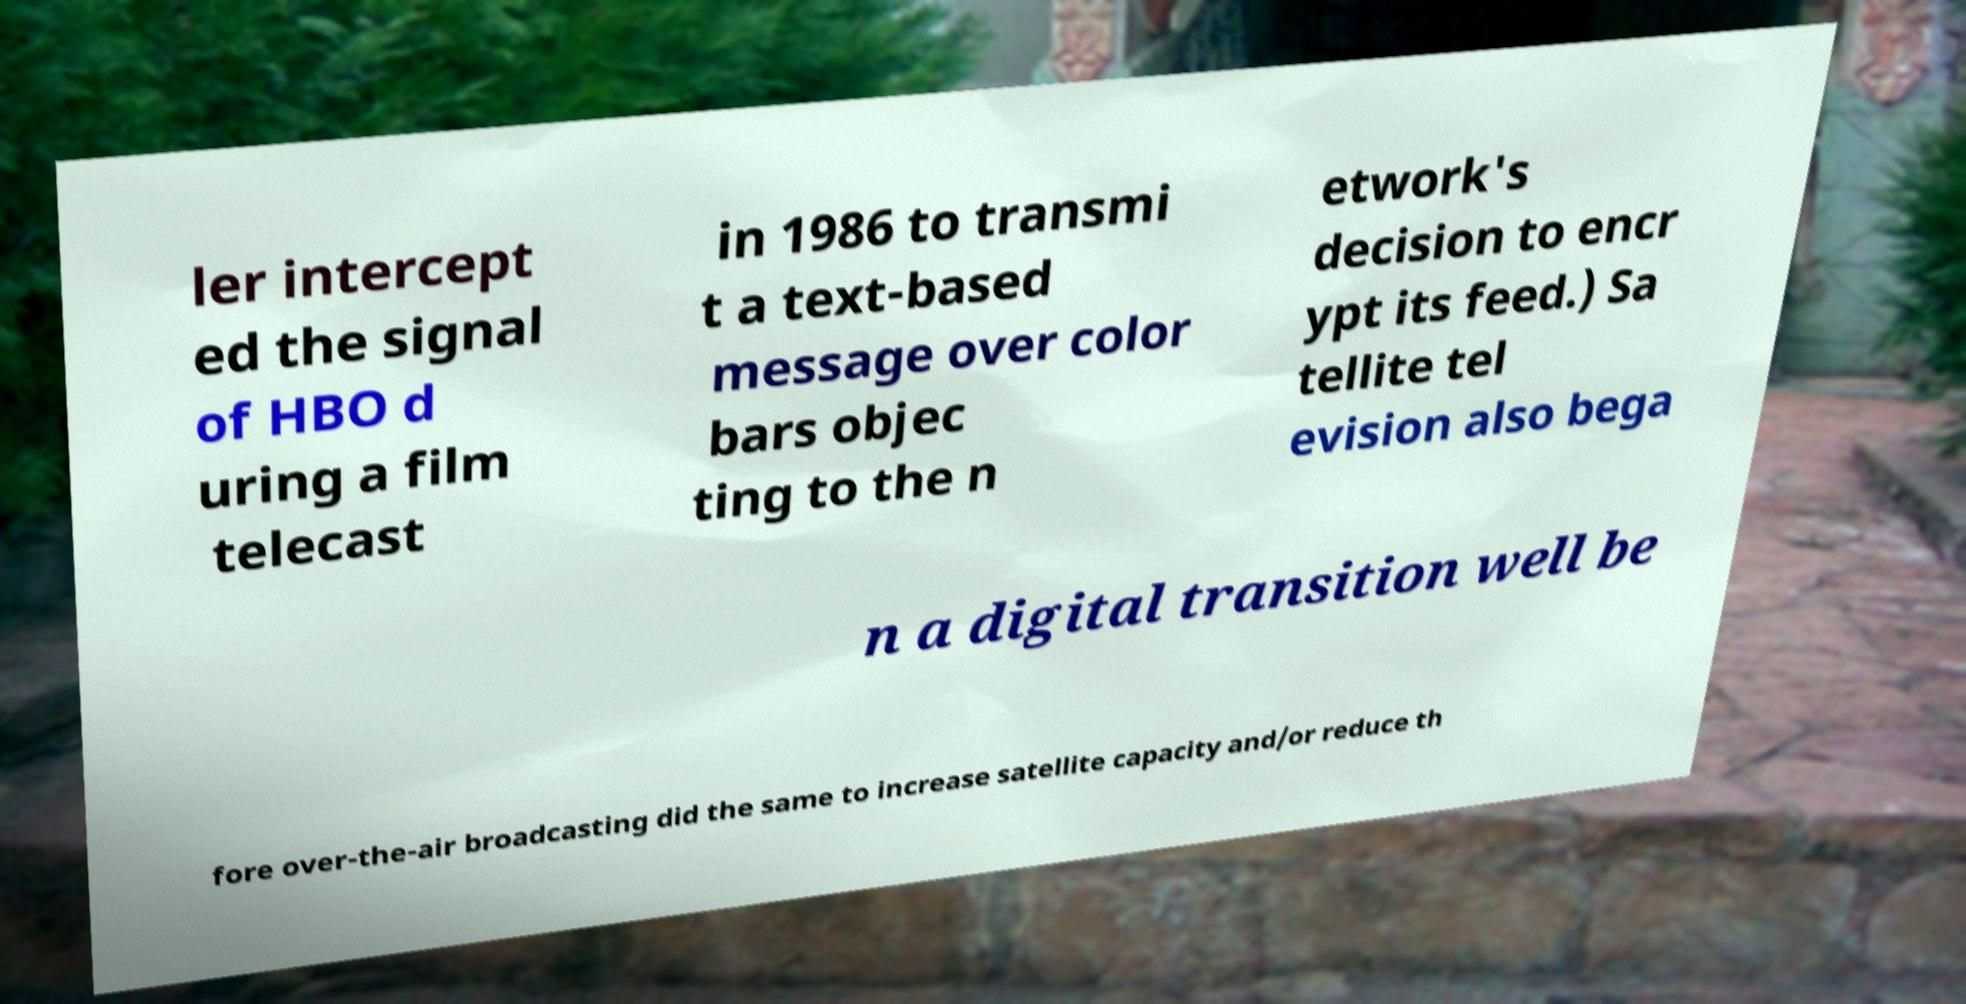Please read and relay the text visible in this image. What does it say? ler intercept ed the signal of HBO d uring a film telecast in 1986 to transmi t a text-based message over color bars objec ting to the n etwork's decision to encr ypt its feed.) Sa tellite tel evision also bega n a digital transition well be fore over-the-air broadcasting did the same to increase satellite capacity and/or reduce th 